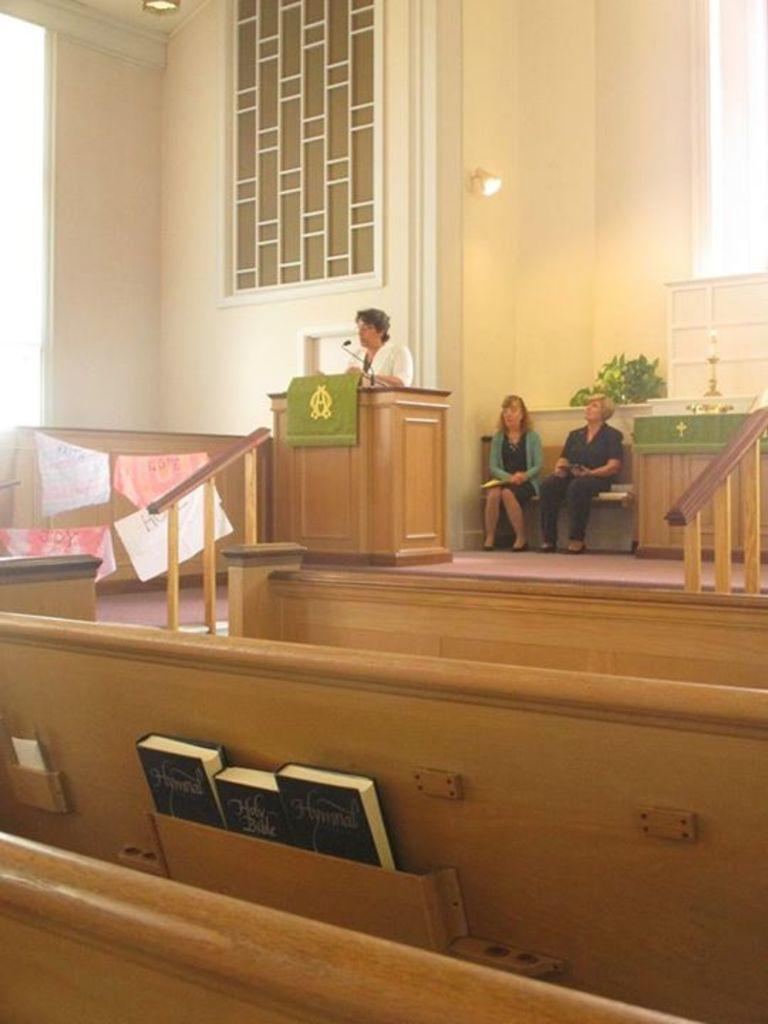How many people are visible in the image? There are two men seated and one woman standing, making a total of three people visible in the image. What is the woman doing in the image? The woman is standing at a podium and speaking with the help of a microphone. What objects can be seen near the woman? There are three books in a stand near the woman. What type of vessel is being used by the expert in the image? There is no vessel or expert present in the image. The woman is speaking at a podium with the help of a microphone, but she is not identified as an expert, and there is no vessel mentioned in the facts. 